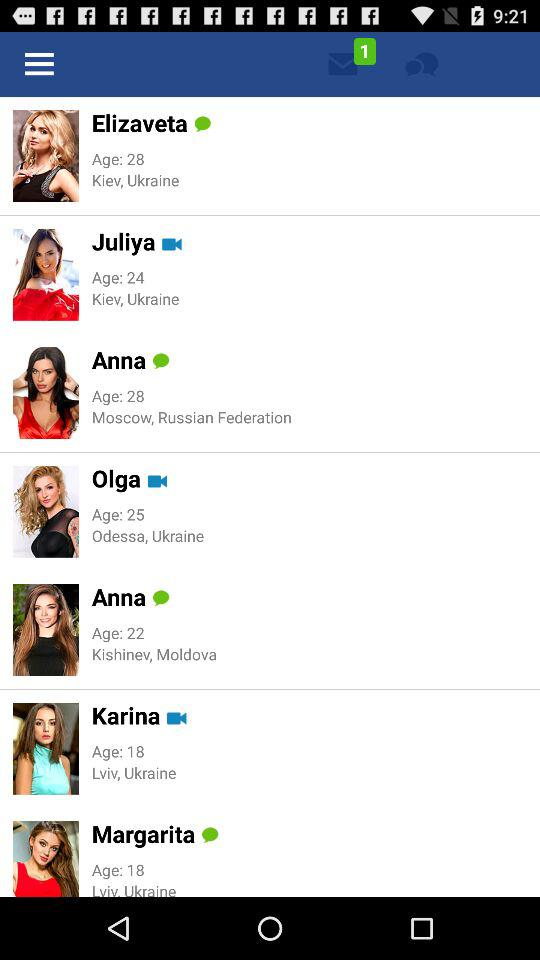How many of the women are wearing red dresses?
Answer the question using a single word or phrase. 3 